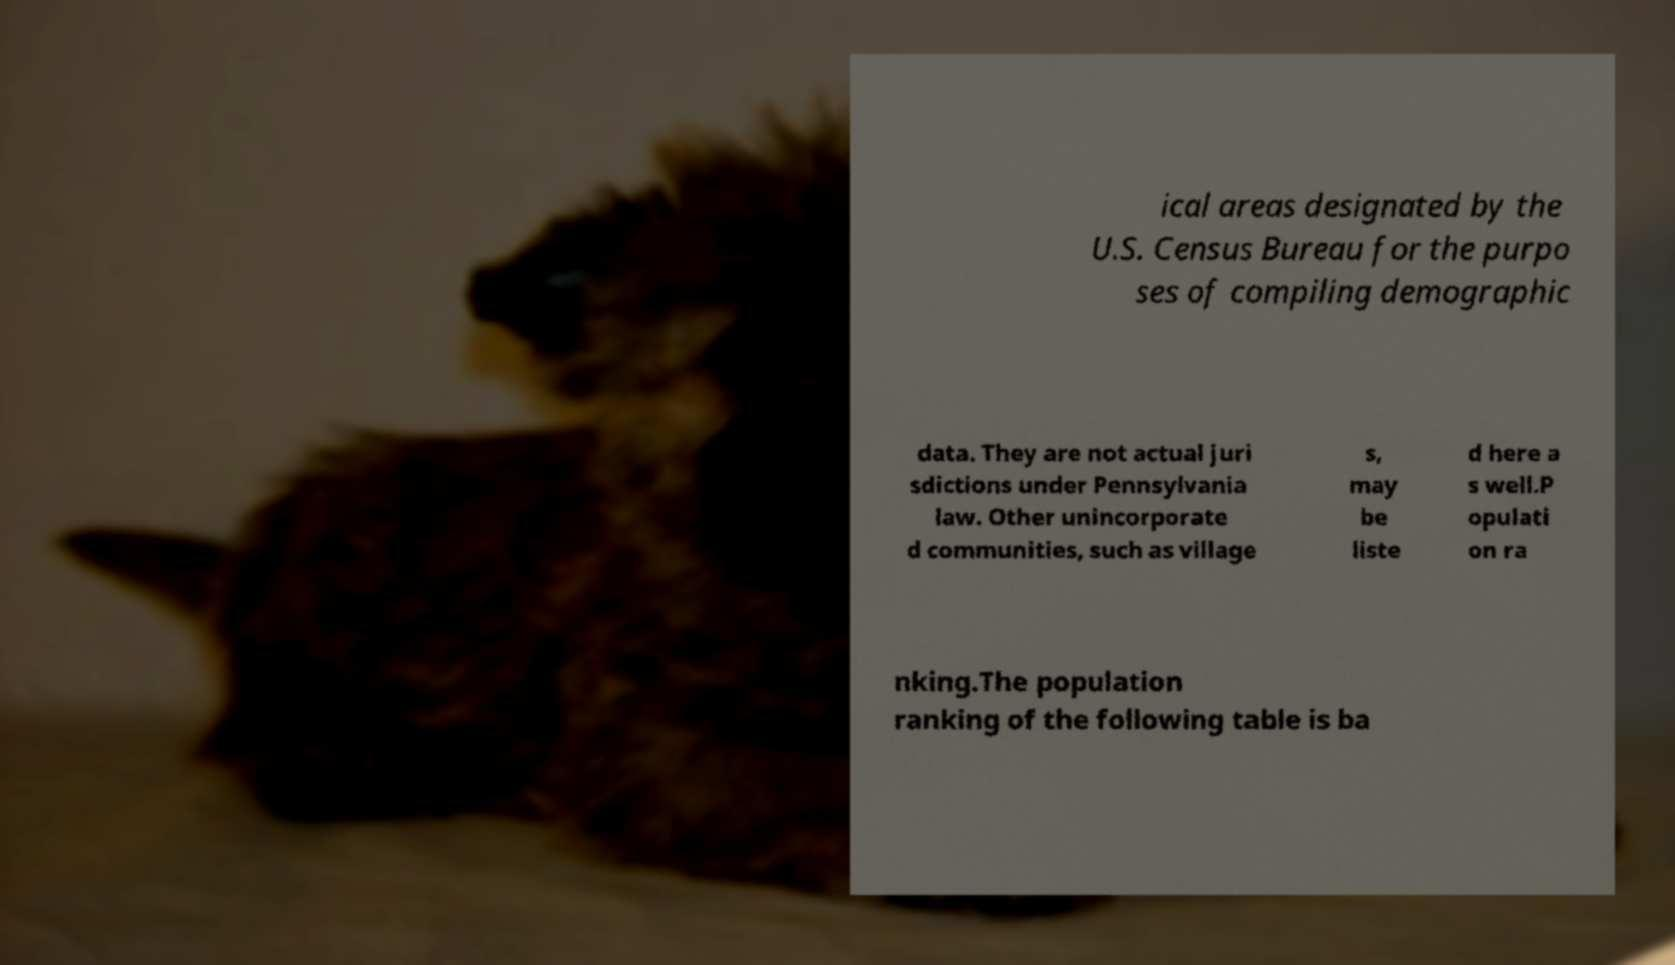Can you read and provide the text displayed in the image?This photo seems to have some interesting text. Can you extract and type it out for me? ical areas designated by the U.S. Census Bureau for the purpo ses of compiling demographic data. They are not actual juri sdictions under Pennsylvania law. Other unincorporate d communities, such as village s, may be liste d here a s well.P opulati on ra nking.The population ranking of the following table is ba 